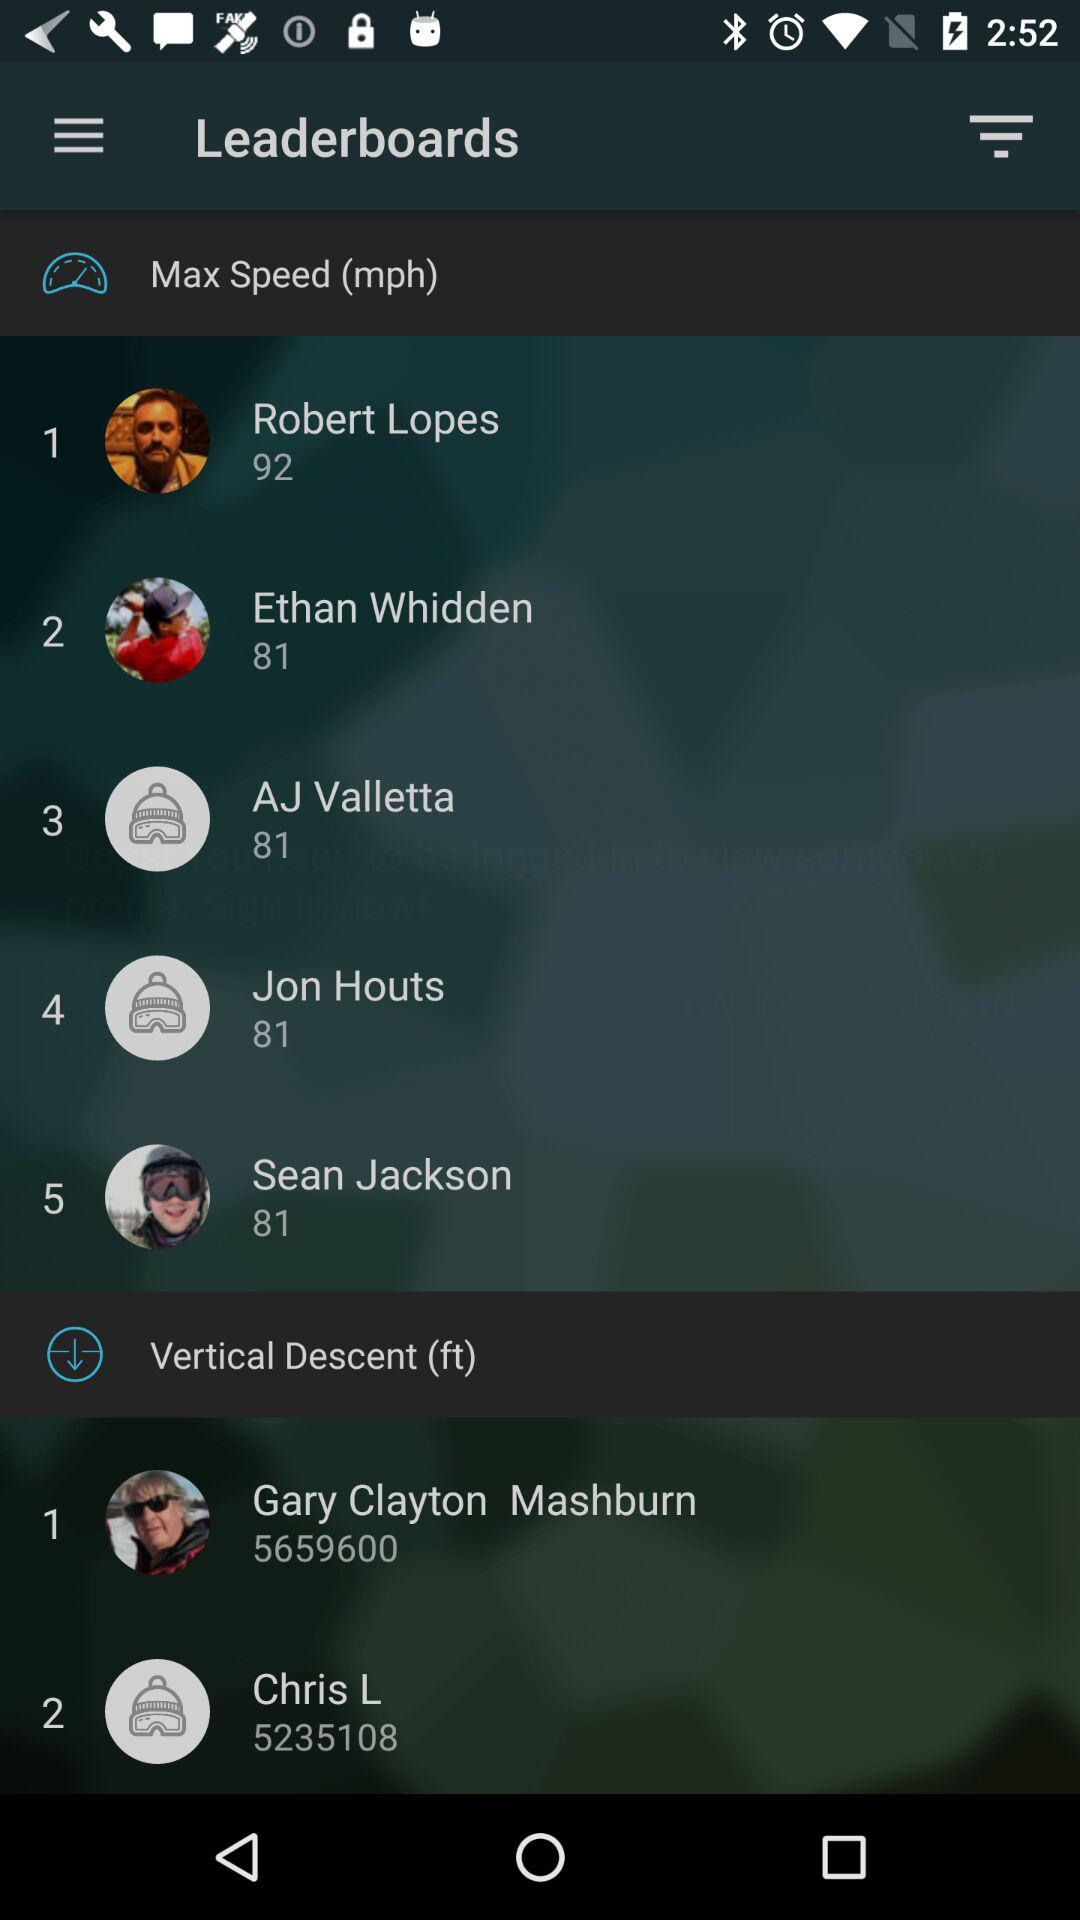What is the unit of speed? The unit of speed is mph. 